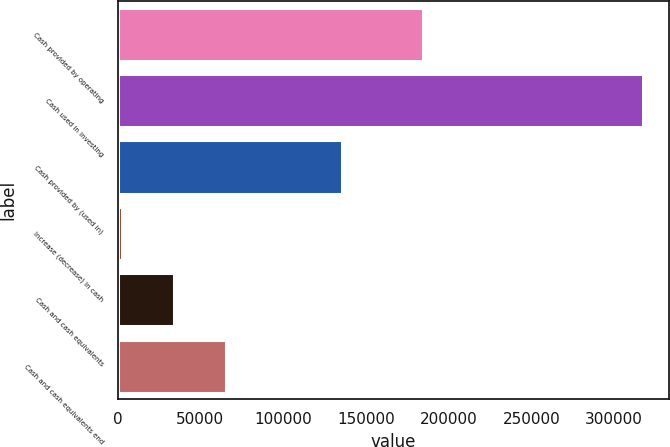Convert chart to OTSL. <chart><loc_0><loc_0><loc_500><loc_500><bar_chart><fcel>Cash provided by operating<fcel>Cash used in investing<fcel>Cash provided by (used in)<fcel>Increase (decrease) in cash<fcel>Cash and cash equivalents<fcel>Cash and cash equivalents end<nl><fcel>184401<fcel>317429<fcel>135884<fcel>2856<fcel>34313.3<fcel>65770.6<nl></chart> 